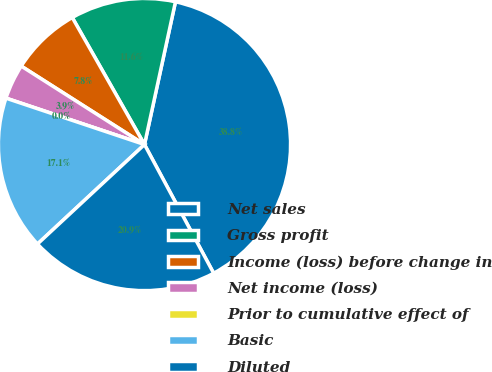Convert chart. <chart><loc_0><loc_0><loc_500><loc_500><pie_chart><fcel>Net sales<fcel>Gross profit<fcel>Income (loss) before change in<fcel>Net income (loss)<fcel>Prior to cumulative effect of<fcel>Basic<fcel>Diluted<nl><fcel>38.75%<fcel>11.63%<fcel>7.75%<fcel>3.88%<fcel>0.0%<fcel>17.06%<fcel>20.93%<nl></chart> 